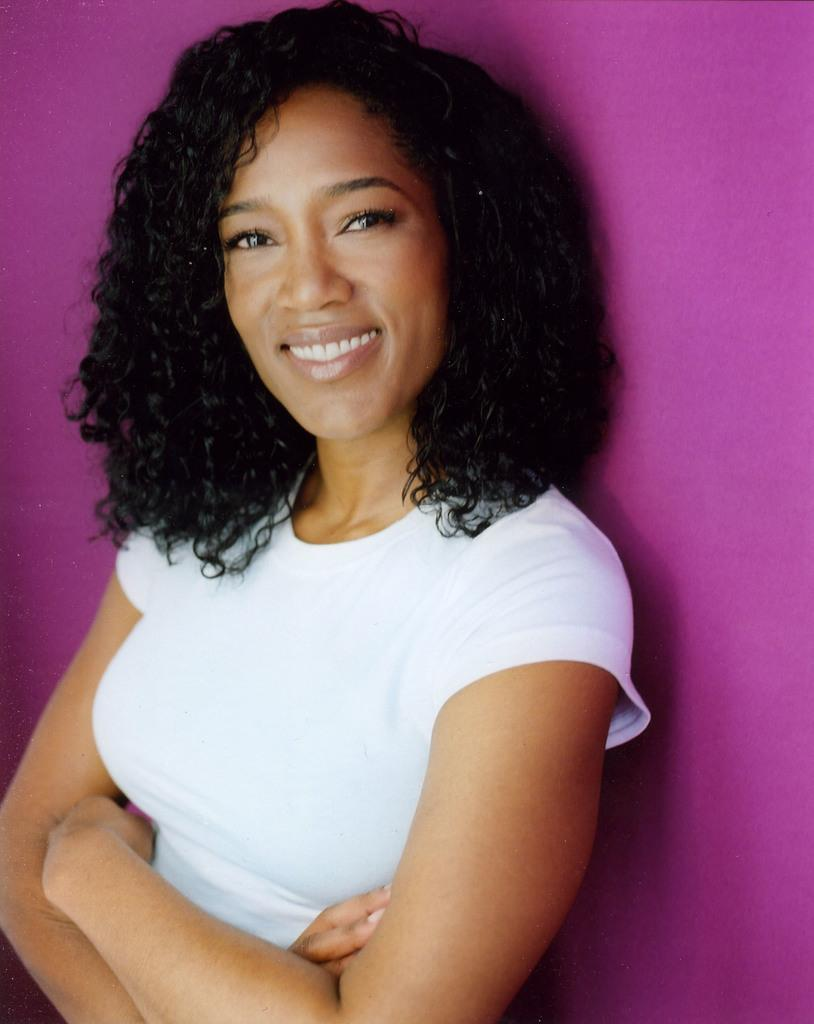What is the main subject of the image? There is a woman standing in the image. What is the woman wearing? The woman is wearing a white t-shirt. What can be seen in the background of the image? There is a wall in the background of the image. What type of boot is the woman wearing in the image? The provided facts do not mention any boots; the woman is wearing a white t-shirt. 